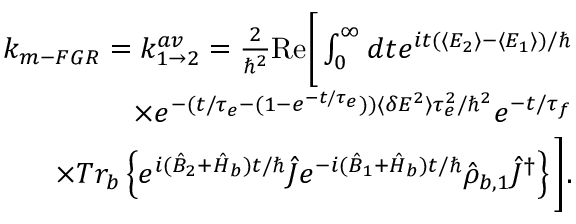<formula> <loc_0><loc_0><loc_500><loc_500>\begin{array} { r l r } & { k _ { m - F G R } = k _ { 1 \rightarrow 2 } ^ { a v } = \frac { 2 } { \hbar { ^ } { 2 } } R e \left [ \int _ { 0 } ^ { \infty } d t e ^ { i t ( \langle E _ { 2 } \rangle - \langle E _ { 1 } \rangle ) / } } \\ & { \times e ^ { - ( t / \tau _ { e } - ( 1 - e ^ { - t / \tau _ { e } } ) ) \langle \delta E ^ { 2 } \rangle \tau _ { e } ^ { 2 } / \hbar { ^ } { 2 } } e ^ { - t / \tau _ { f } } } \\ & { \times T r _ { b } \left \{ e ^ { i ( \hat { B } _ { 2 } + \hat { H } _ { b } ) t / } \hat { J } e ^ { - i ( \hat { B } _ { 1 } + \hat { H } _ { b } ) t / } \hat { \rho } _ { b , 1 } \hat { J } ^ { \dagger } \right \} \right ] . } \end{array}</formula> 